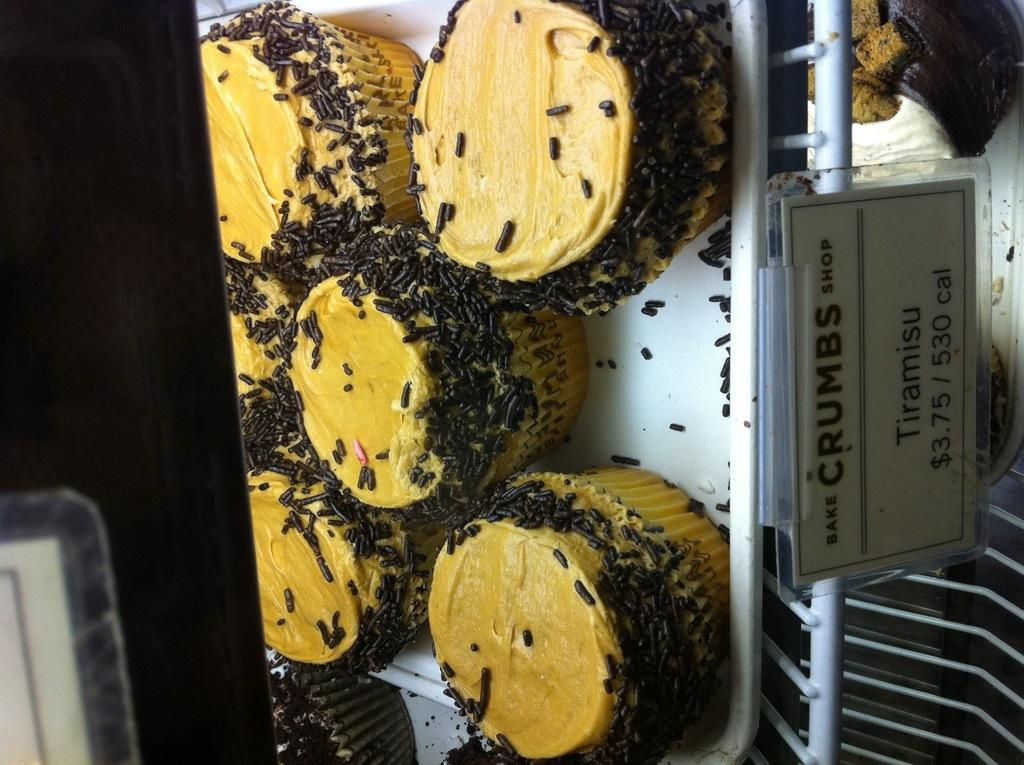What is on the display table in the image? There is food on a display table in the image. What information can be found on the board on the display table? There is a board with text and prices on the display table. Can you describe the object on the left side of the image? Unfortunately, the facts provided do not give any information about the object on the left side of the image. Are there any birds in the image? There is no mention of birds in the provided facts, so we cannot determine if there are any birds in the image. Can you describe the drawer in the image? There is no mention of a drawer in the provided facts, so we cannot describe a drawer in the image. 